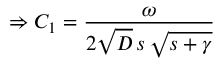<formula> <loc_0><loc_0><loc_500><loc_500>\Rightarrow C _ { 1 } = \frac { \omega } { 2 \sqrt { D } \, s \, \sqrt { s + \gamma } }</formula> 